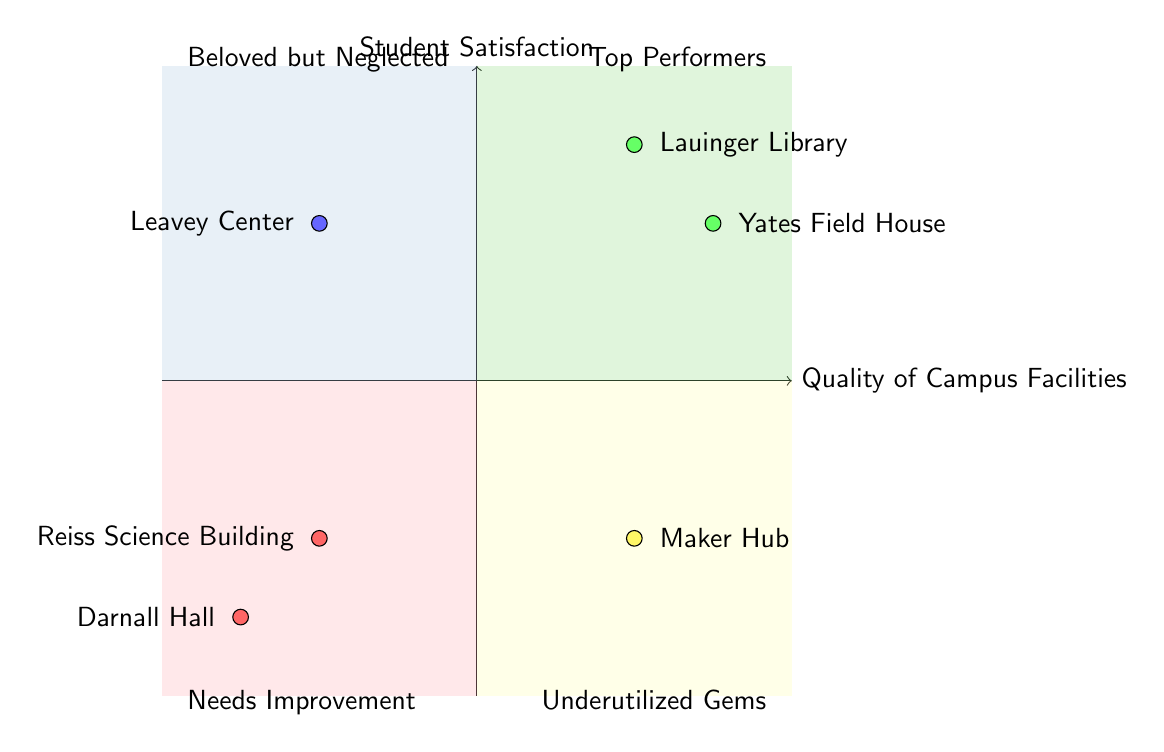What facilities are in the "Top Performers" quadrant? The "Top Performers" quadrant contains facilities that have high quality and high student satisfaction. In this quadrant, the facilities listed are Lauinger Library and Yates Field House.
Answer: Lauinger Library, Yates Field House How many facilities are placed in the "Needs Improvement" quadrant? The "Needs Improvement" quadrant has facilities that are rated low in both quality and satisfaction. There are two facilities listed in this quadrant: Darnall Hall and Reiss Science Building.
Answer: 2 Which facility is rated as "High" in the "Beloved but Neglected" quadrant? The "Beloved but Neglected" quadrant represents facilities that have high student satisfaction but low quality. The facility listed in this quadrant and rated as "High" is the Leavey Center.
Answer: Leavey Center What is the student satisfaction level for the Maker Hub? The Maker Hub is located in the "Underutilized Gems" quadrant, which indicates that it has moderate quality and satisfaction levels. Its specific satisfaction rating is referred to as "Moderate."
Answer: Moderate Which quadrant contains facilities with low quality but high satisfaction? The quadrant that includes facilities with low quality but high satisfaction is the "Beloved but Neglected" quadrant.
Answer: Beloved but Neglected Is there any facility listed with "Low" satisfaction in the "Top Performers" quadrant? Upon reviewing the "Top Performers" quadrant, there are no facilities mentioned that have low satisfaction. In fact, all listed facilities in this quadrant are rated as high in satisfaction.
Answer: No How does the quality of facilities in the "Needs Improvement" quadrant compare to those in the "Top Performers" quadrant? The facilities in the "Needs Improvement" quadrant are rated low in quality, while those in the "Top Performers" quadrant are rated high in quality. This creates a clear distinction between the two quadrants based on the quality of facilities.
Answer: Low vs High Which quadrant has the least student satisfaction overall? The "Needs Improvement" quadrant shows the lowest overall student satisfaction as both Darnall Hall and Reiss Science Building are rated low in satisfaction, making this quadrant the least satisfactory.
Answer: Needs Improvement 